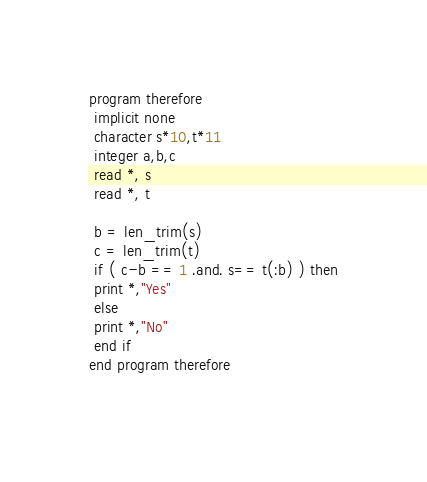<code> <loc_0><loc_0><loc_500><loc_500><_FORTRAN_>program therefore
 implicit none
 character s*10,t*11
 integer a,b,c
 read *, s
 read *, t
 
 b = len_trim(s)
 c = len_trim(t)
 if ( c-b == 1 .and. s== t(:b) ) then
 print *,"Yes"
 else
 print *,"No"
 end if
end program therefore
 
</code> 